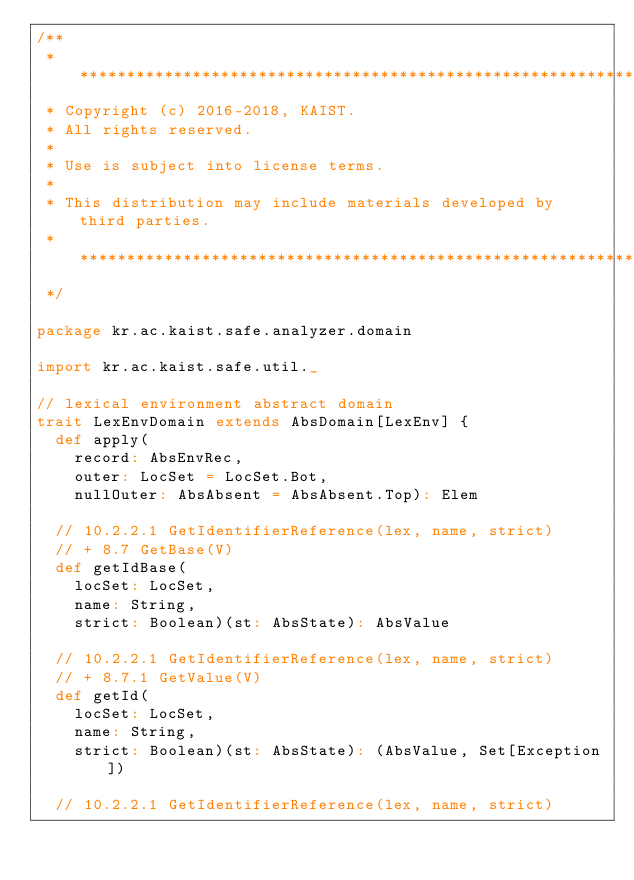Convert code to text. <code><loc_0><loc_0><loc_500><loc_500><_Scala_>/**
 * *****************************************************************************
 * Copyright (c) 2016-2018, KAIST.
 * All rights reserved.
 *
 * Use is subject into license terms.
 *
 * This distribution may include materials developed by third parties.
 * ****************************************************************************
 */

package kr.ac.kaist.safe.analyzer.domain

import kr.ac.kaist.safe.util._

// lexical environment abstract domain
trait LexEnvDomain extends AbsDomain[LexEnv] {
  def apply(
    record: AbsEnvRec,
    outer: LocSet = LocSet.Bot,
    nullOuter: AbsAbsent = AbsAbsent.Top): Elem

  // 10.2.2.1 GetIdentifierReference(lex, name, strict)
  // + 8.7 GetBase(V)
  def getIdBase(
    locSet: LocSet,
    name: String,
    strict: Boolean)(st: AbsState): AbsValue

  // 10.2.2.1 GetIdentifierReference(lex, name, strict)
  // + 8.7.1 GetValue(V)
  def getId(
    locSet: LocSet,
    name: String,
    strict: Boolean)(st: AbsState): (AbsValue, Set[Exception])

  // 10.2.2.1 GetIdentifierReference(lex, name, strict)</code> 